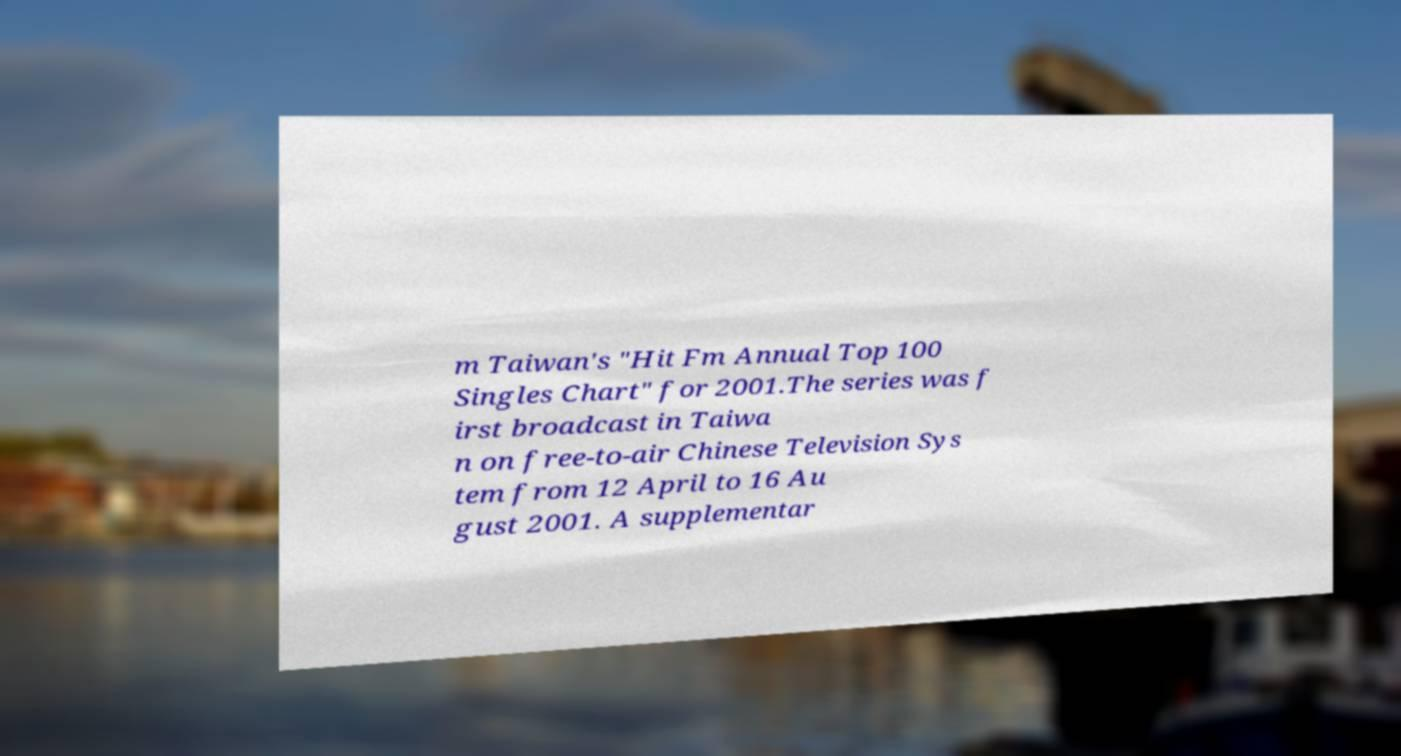Can you accurately transcribe the text from the provided image for me? m Taiwan's "Hit Fm Annual Top 100 Singles Chart" for 2001.The series was f irst broadcast in Taiwa n on free-to-air Chinese Television Sys tem from 12 April to 16 Au gust 2001. A supplementar 